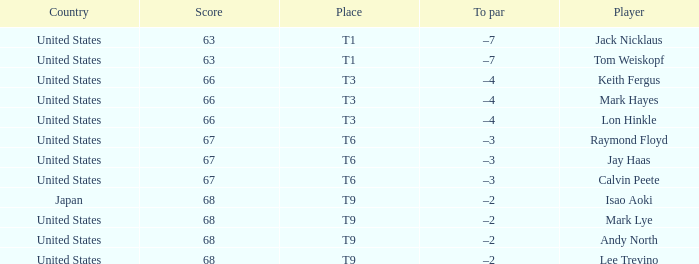What is the total number of Score, when Country is "United States", and when Player is "Lee Trevino"? 1.0. 